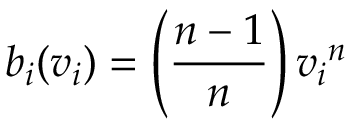<formula> <loc_0><loc_0><loc_500><loc_500>b _ { i } ( v _ { i } ) = \left ( { \frac { n - 1 } { n } } \right ) { v _ { i } } ^ { n }</formula> 